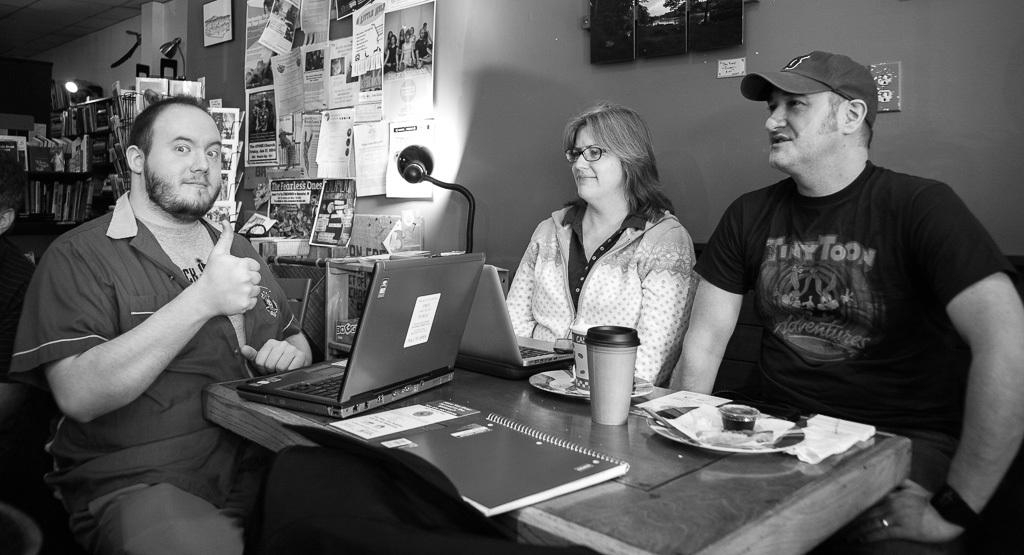How many people are in the image? There are three people in the image. Can you describe the gender of each person? Two of the people are men, and one is a woman. What is one of the men wearing on his head? One of the men is wearing a cap. What can be seen in the background of the image? There is a wall in the background of the image. What is on the wall? There are sticky papers on the wall. Can you describe the lighting in the image? There is light visible in the image. What type of furniture is being used by the beggar in the image? A: There is no beggar present in the image, and therefore no furniture being used by a beggar. How many bananas are being held by the woman in the image? There are no bananas visible in the image. 